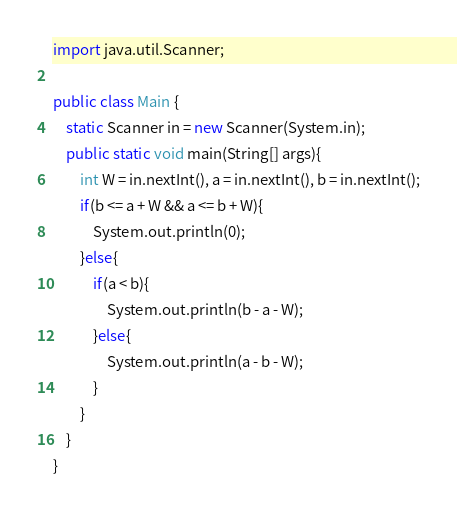Convert code to text. <code><loc_0><loc_0><loc_500><loc_500><_Java_>import java.util.Scanner;
 
public class Main {
	static Scanner in = new Scanner(System.in);
	public static void main(String[] args){
		int W = in.nextInt(), a = in.nextInt(), b = in.nextInt();
		if(b <= a + W && a <= b + W){
			System.out.println(0);
		}else{
			if(a < b){
				System.out.println(b - a - W);
			}else{
				System.out.println(a - b - W);
			}
		}
	}
}</code> 